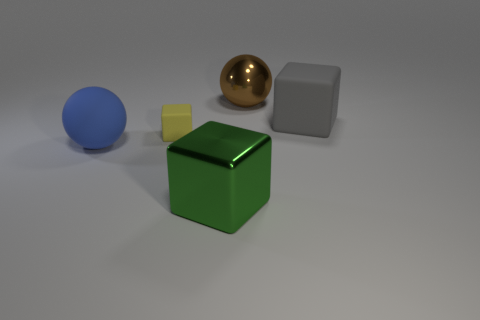Add 3 big brown metal objects. How many objects exist? 8 Subtract all green blocks. How many blocks are left? 2 Subtract all green cubes. How many cubes are left? 2 Subtract all blocks. How many objects are left? 2 Subtract 2 spheres. How many spheres are left? 0 Add 5 matte cubes. How many matte cubes are left? 7 Add 3 large metal balls. How many large metal balls exist? 4 Subtract 0 brown cubes. How many objects are left? 5 Subtract all green blocks. Subtract all red cylinders. How many blocks are left? 2 Subtract all purple cylinders. How many yellow blocks are left? 1 